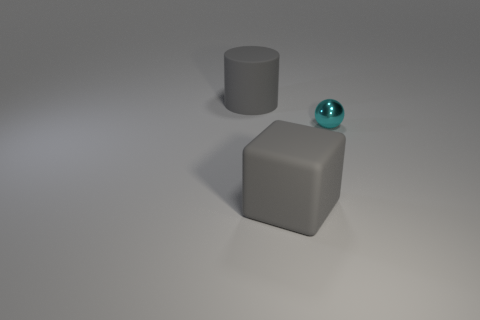Is there anything else that has the same shape as the cyan metal thing?
Provide a succinct answer. No. What number of large rubber cubes are the same color as the big cylinder?
Make the answer very short. 1. What is the size of the gray matte object that is behind the tiny sphere on the right side of the large matte block?
Provide a short and direct response. Large. Is there a gray matte object of the same size as the block?
Make the answer very short. Yes. There is a rubber object that is in front of the gray matte cylinder; does it have the same size as the cyan sphere behind the big gray block?
Your answer should be compact. No. There is a big gray matte thing that is in front of the gray object behind the tiny metal object; what is its shape?
Ensure brevity in your answer.  Cube. There is a ball; what number of tiny metal objects are behind it?
Make the answer very short. 0. What is the color of the cylinder that is the same material as the block?
Keep it short and to the point. Gray. Is the size of the gray matte block the same as the thing behind the shiny thing?
Offer a very short reply. Yes. There is a cyan thing behind the large gray matte thing that is in front of the big cylinder that is left of the tiny sphere; how big is it?
Give a very brief answer. Small. 